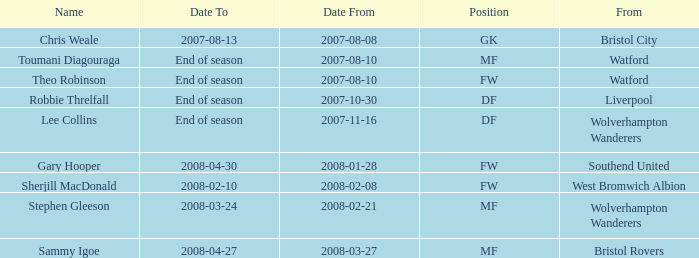What was the from for the Date From of 2007-08-08? Bristol City. 